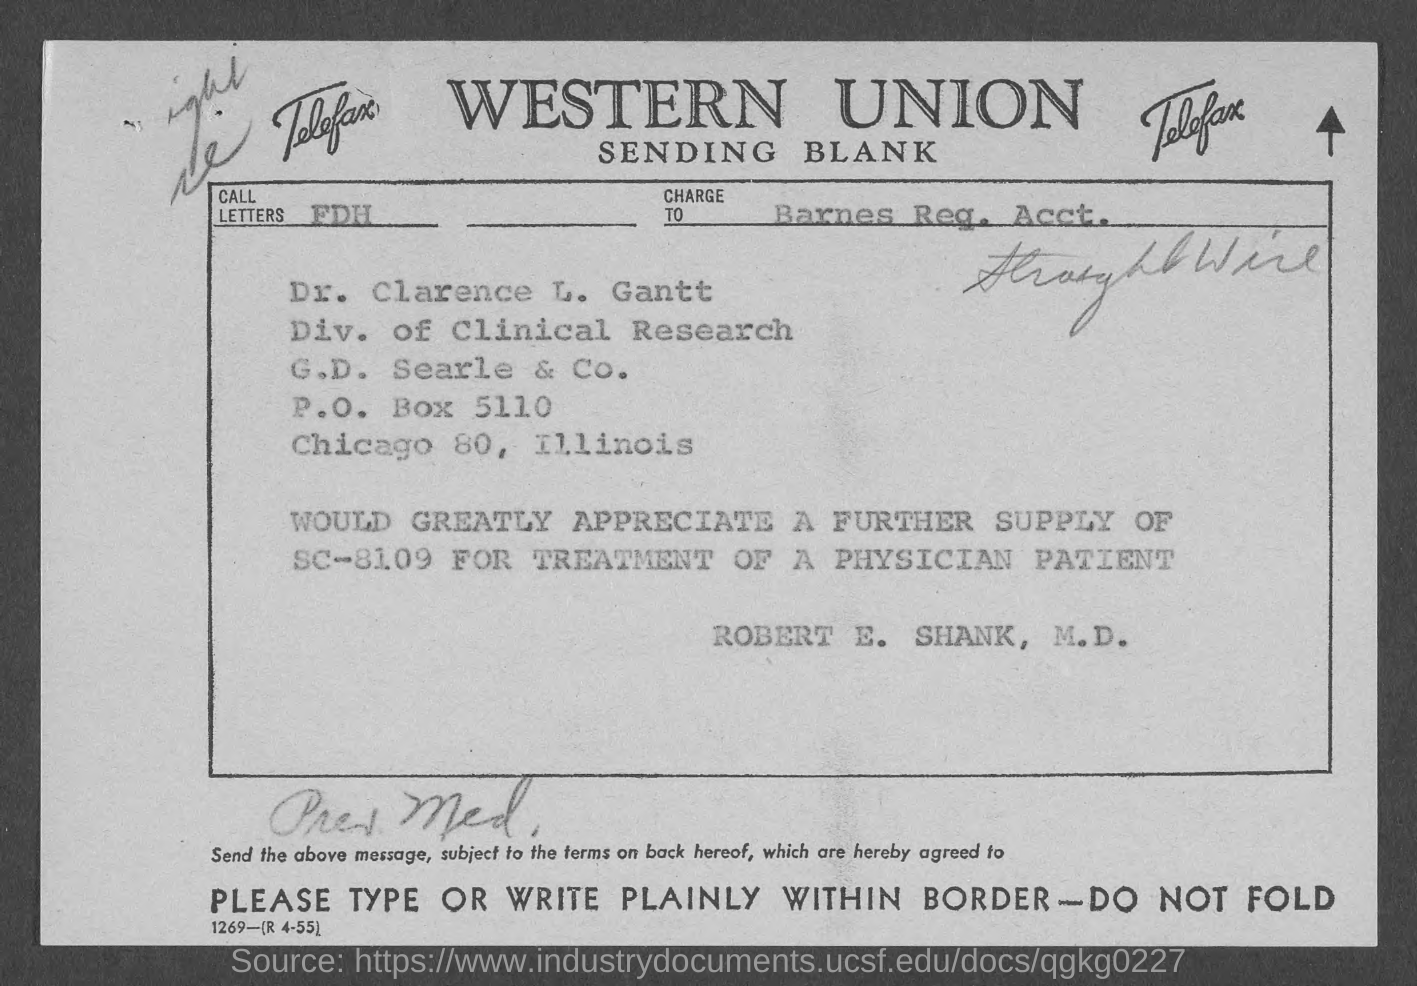What are the call letters?
Give a very brief answer. FDH. 